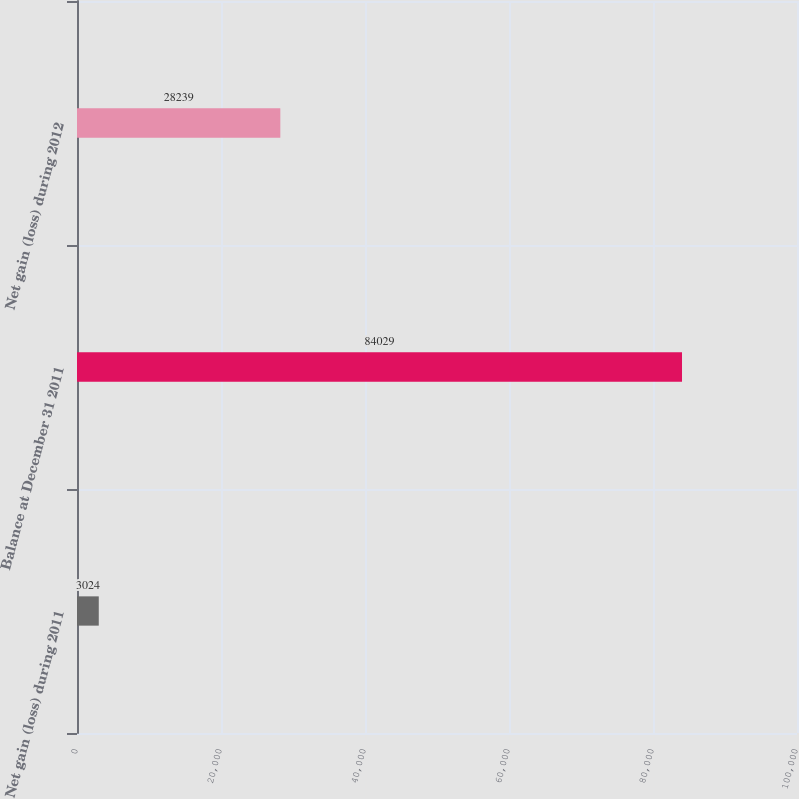Convert chart to OTSL. <chart><loc_0><loc_0><loc_500><loc_500><bar_chart><fcel>Net gain (loss) during 2011<fcel>Balance at December 31 2011<fcel>Net gain (loss) during 2012<nl><fcel>3024<fcel>84029<fcel>28239<nl></chart> 